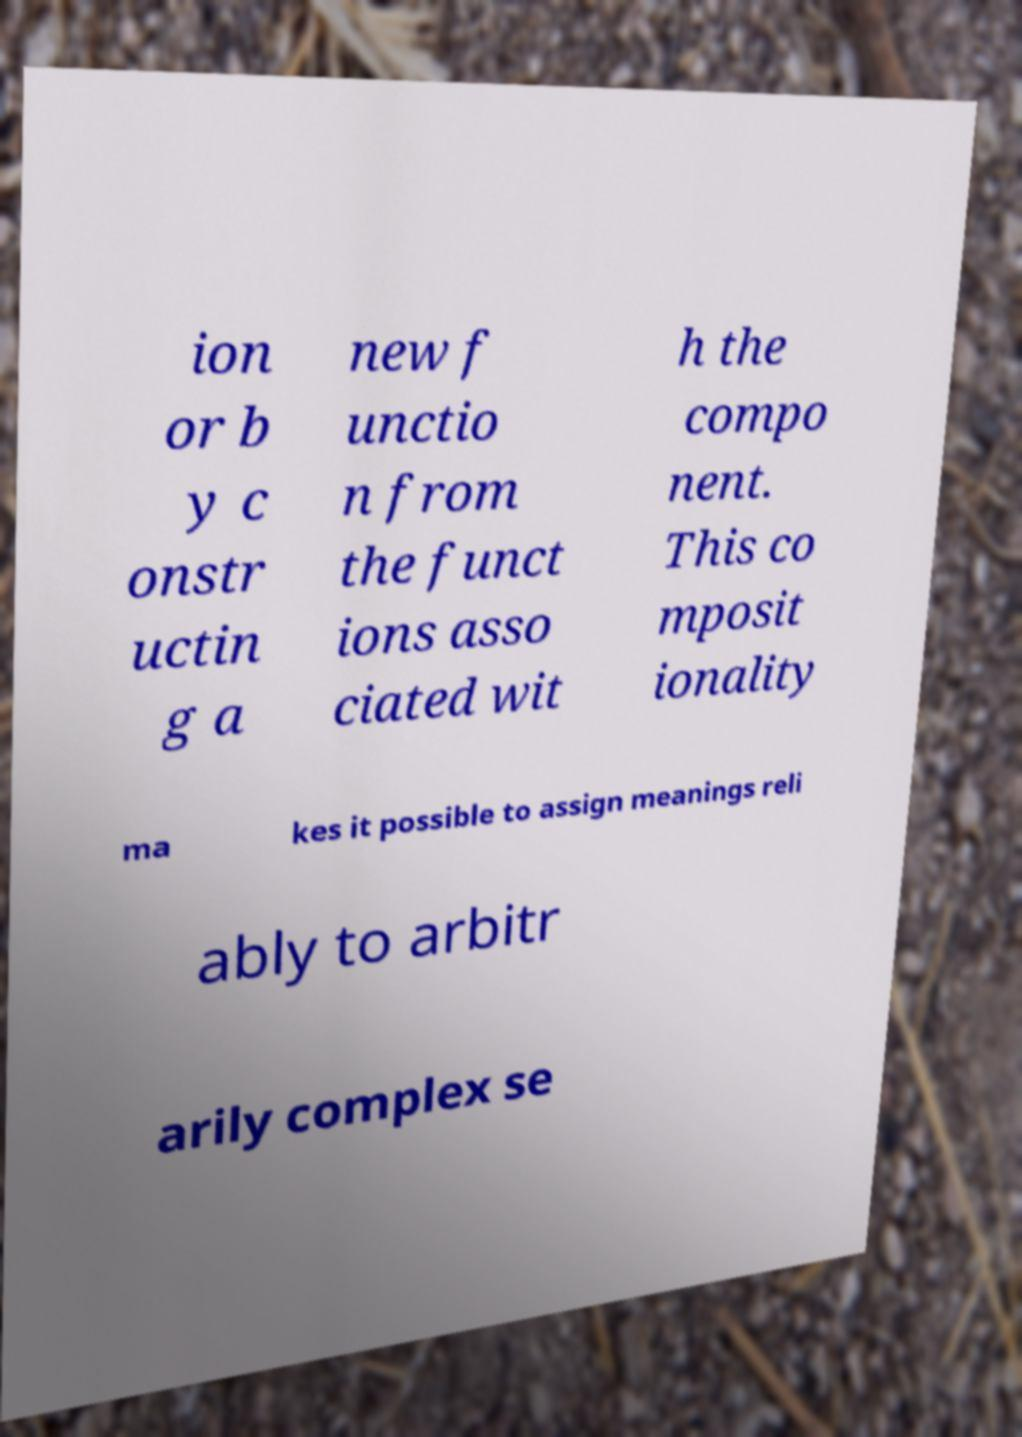Please read and relay the text visible in this image. What does it say? ion or b y c onstr uctin g a new f unctio n from the funct ions asso ciated wit h the compo nent. This co mposit ionality ma kes it possible to assign meanings reli ably to arbitr arily complex se 